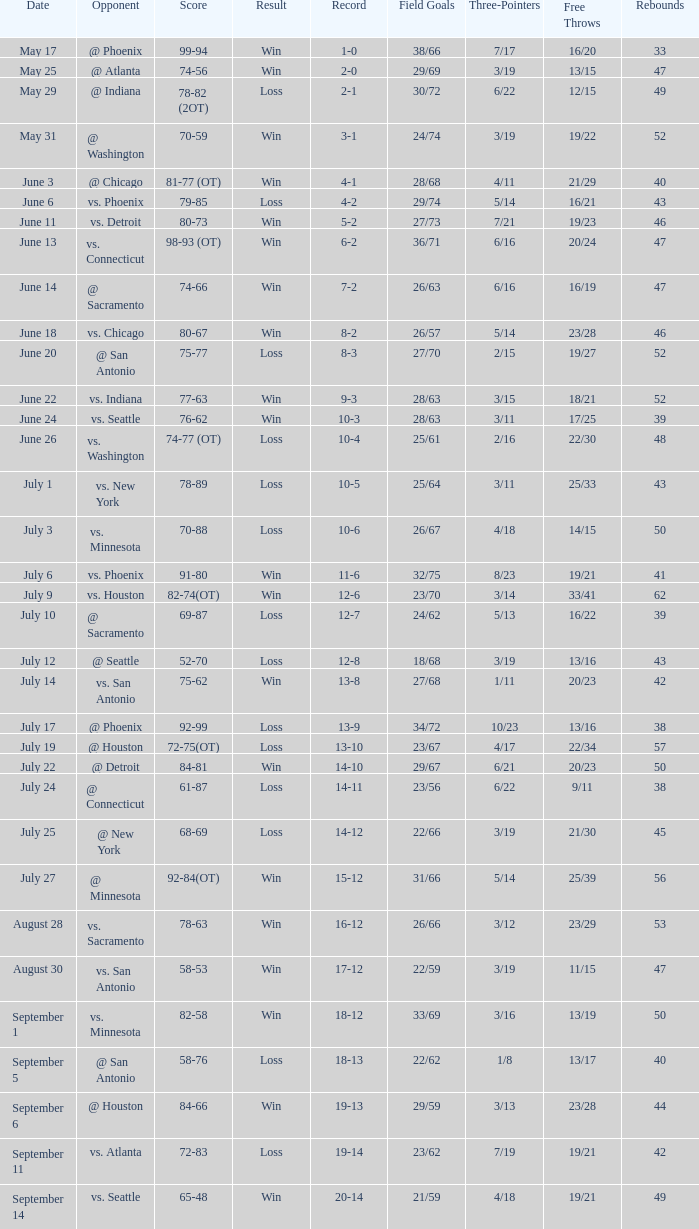Parse the full table. {'header': ['Date', 'Opponent', 'Score', 'Result', 'Record', 'Field Goals', 'Three-Pointers', 'Free Throws', 'Rebounds'], 'rows': [['May 17', '@ Phoenix', '99-94', 'Win', '1-0', '38/66', '7/17', '16/20', '33'], ['May 25', '@ Atlanta', '74-56', 'Win', '2-0', '29/69', '3/19', '13/15', '47'], ['May 29', '@ Indiana', '78-82 (2OT)', 'Loss', '2-1', '30/72', '6/22', '12/15', '49'], ['May 31', '@ Washington', '70-59', 'Win', '3-1', '24/74', '3/19', '19/22', '52'], ['June 3', '@ Chicago', '81-77 (OT)', 'Win', '4-1', '28/68', '4/11', '21/29', '40'], ['June 6', 'vs. Phoenix', '79-85', 'Loss', '4-2', '29/74', '5/14', '16/21', '43'], ['June 11', 'vs. Detroit', '80-73', 'Win', '5-2', '27/73', '7/21', '19/23', '46'], ['June 13', 'vs. Connecticut', '98-93 (OT)', 'Win', '6-2', '36/71', '6/16', '20/24', '47'], ['June 14', '@ Sacramento', '74-66', 'Win', '7-2', '26/63', '6/16', '16/19', '47'], ['June 18', 'vs. Chicago', '80-67', 'Win', '8-2', '26/57', '5/14', '23/28', '46'], ['June 20', '@ San Antonio', '75-77', 'Loss', '8-3', '27/70', '2/15', '19/27', '52'], ['June 22', 'vs. Indiana', '77-63', 'Win', '9-3', '28/63', '3/15', '18/21', '52'], ['June 24', 'vs. Seattle', '76-62', 'Win', '10-3', '28/63', '3/11', '17/25', '39'], ['June 26', 'vs. Washington', '74-77 (OT)', 'Loss', '10-4', '25/61', '2/16', '22/30', '48'], ['July 1', 'vs. New York', '78-89', 'Loss', '10-5', '25/64', '3/11', '25/33', '43'], ['July 3', 'vs. Minnesota', '70-88', 'Loss', '10-6', '26/67', '4/18', '14/15', '50'], ['July 6', 'vs. Phoenix', '91-80', 'Win', '11-6', '32/75', '8/23', '19/21', '41'], ['July 9', 'vs. Houston', '82-74(OT)', 'Win', '12-6', '23/70', '3/14', '33/41', '62'], ['July 10', '@ Sacramento', '69-87', 'Loss', '12-7', '24/62', '5/13', '16/22', '39'], ['July 12', '@ Seattle', '52-70', 'Loss', '12-8', '18/68', '3/19', '13/16', '43'], ['July 14', 'vs. San Antonio', '75-62', 'Win', '13-8', '27/68', '1/11', '20/23', '42'], ['July 17', '@ Phoenix', '92-99', 'Loss', '13-9', '34/72', '10/23', '13/16', '38'], ['July 19', '@ Houston', '72-75(OT)', 'Loss', '13-10', '23/67', '4/17', '22/34', '57'], ['July 22', '@ Detroit', '84-81', 'Win', '14-10', '29/67', '6/21', '20/23', '50'], ['July 24', '@ Connecticut', '61-87', 'Loss', '14-11', '23/56', '6/22', '9/11', '38'], ['July 25', '@ New York', '68-69', 'Loss', '14-12', '22/66', '3/19', '21/30', '45'], ['July 27', '@ Minnesota', '92-84(OT)', 'Win', '15-12', '31/66', '5/14', '25/39', '56'], ['August 28', 'vs. Sacramento', '78-63', 'Win', '16-12', '26/66', '3/12', '23/29', '53'], ['August 30', 'vs. San Antonio', '58-53', 'Win', '17-12', '22/59', '3/19', '11/15', '47'], ['September 1', 'vs. Minnesota', '82-58', 'Win', '18-12', '33/69', '3/16', '13/19', '50'], ['September 5', '@ San Antonio', '58-76', 'Loss', '18-13', '22/62', '1/8', '13/17', '40'], ['September 6', '@ Houston', '84-66', 'Win', '19-13', '29/59', '3/13', '23/28', '44'], ['September 11', 'vs. Atlanta', '72-83', 'Loss', '19-14', '23/62', '7/19', '19/21', '42'], ['September 14', 'vs. Seattle', '65-48', 'Win', '20-14', '21/59', '4/18', '19/21', '49']]} What is the Score of the game @ San Antonio on June 20? 75-77. 